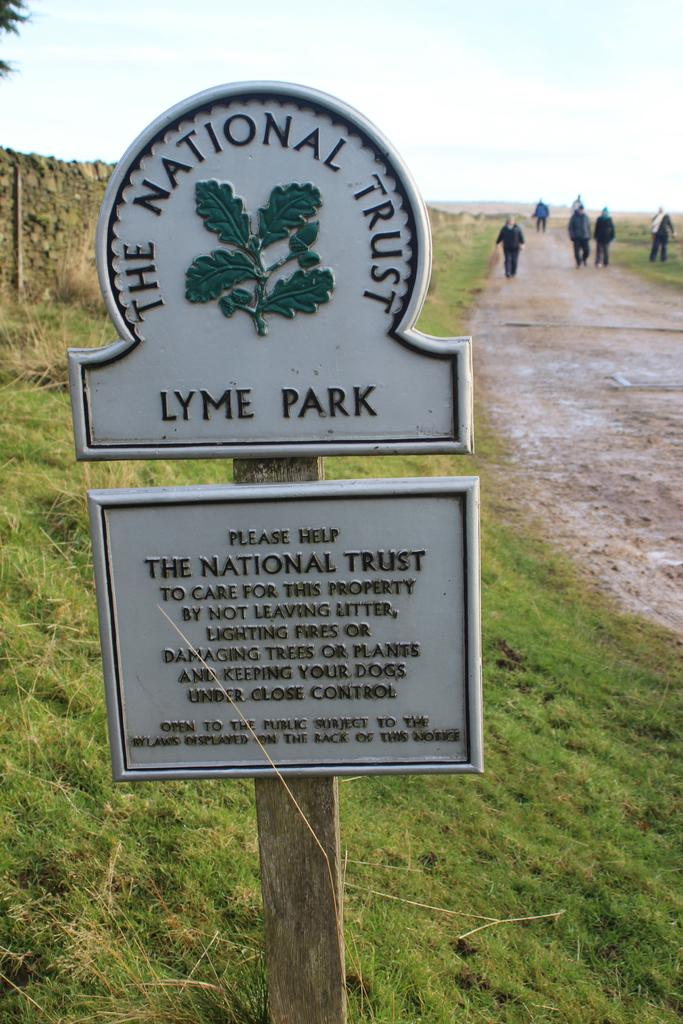What is the main object in the image? There is a sign board in the image. What type of natural environment is visible in the image? There is grass visible in the image. What type of structure is present in the image? There is a wall in the image. Who or what can be seen in the image? There are people present in the image. What is visible in the background of the image? The sky is visible in the image. How many chairs are visible in the image? There are no chairs present in the image. What type of fruit is being held by the people in the image? There is no fruit, such as a banana, visible in the image. 